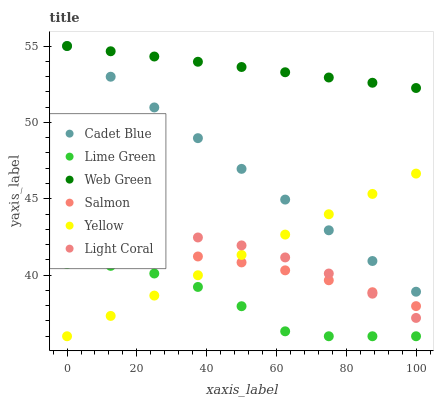Does Lime Green have the minimum area under the curve?
Answer yes or no. Yes. Does Web Green have the maximum area under the curve?
Answer yes or no. Yes. Does Salmon have the minimum area under the curve?
Answer yes or no. No. Does Salmon have the maximum area under the curve?
Answer yes or no. No. Is Cadet Blue the smoothest?
Answer yes or no. Yes. Is Lime Green the roughest?
Answer yes or no. Yes. Is Salmon the smoothest?
Answer yes or no. No. Is Salmon the roughest?
Answer yes or no. No. Does Yellow have the lowest value?
Answer yes or no. Yes. Does Salmon have the lowest value?
Answer yes or no. No. Does Web Green have the highest value?
Answer yes or no. Yes. Does Salmon have the highest value?
Answer yes or no. No. Is Salmon less than Web Green?
Answer yes or no. Yes. Is Salmon greater than Lime Green?
Answer yes or no. Yes. Does Salmon intersect Yellow?
Answer yes or no. Yes. Is Salmon less than Yellow?
Answer yes or no. No. Is Salmon greater than Yellow?
Answer yes or no. No. Does Salmon intersect Web Green?
Answer yes or no. No. 